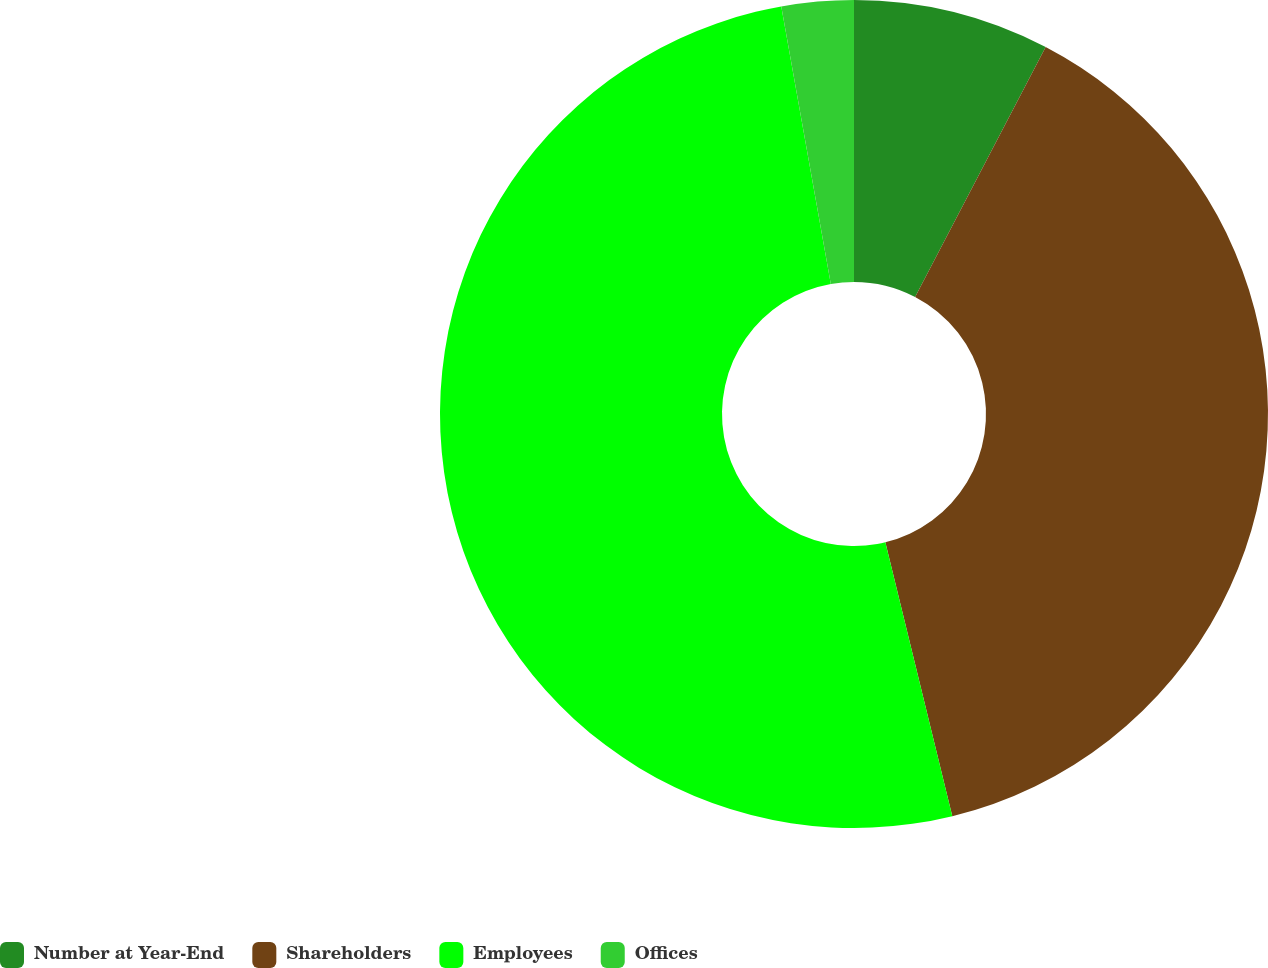Convert chart. <chart><loc_0><loc_0><loc_500><loc_500><pie_chart><fcel>Number at Year-End<fcel>Shareholders<fcel>Employees<fcel>Offices<nl><fcel>7.66%<fcel>38.52%<fcel>51.0%<fcel>2.81%<nl></chart> 